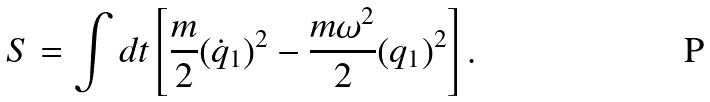Convert formula to latex. <formula><loc_0><loc_0><loc_500><loc_500>S = \int d t \left [ \frac { m } { 2 } ( { \dot { q } } _ { 1 } ) ^ { 2 } - \frac { m \omega ^ { 2 } } { 2 } ( q _ { 1 } ) ^ { 2 } \right ] .</formula> 